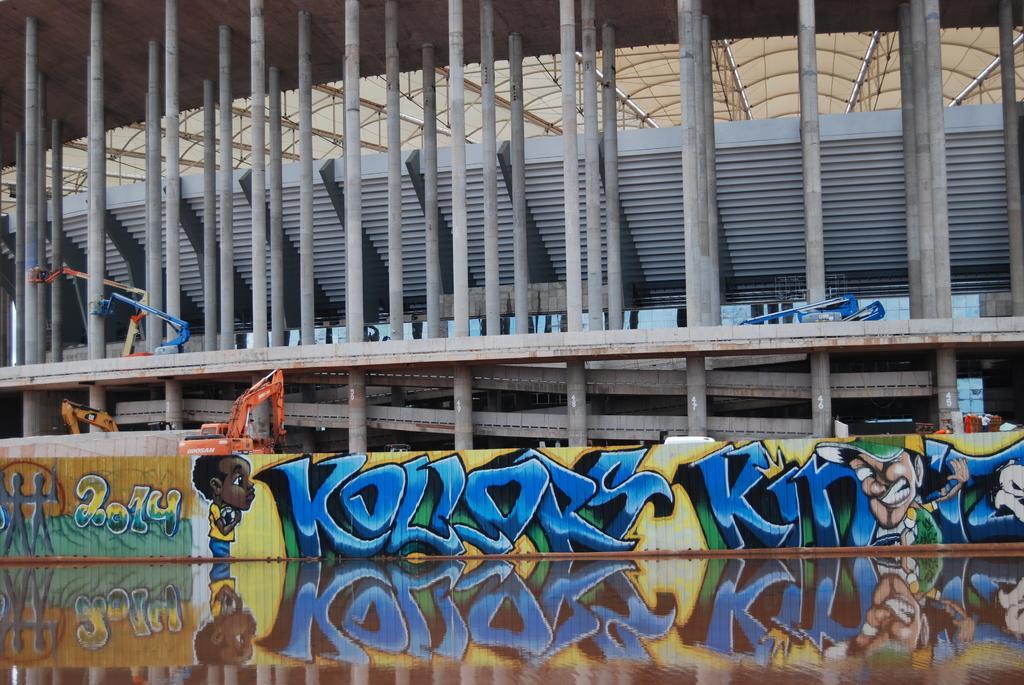Could you give a brief overview of what you see in this image? In the foreground of this image we can see the reflection of the painting of a person and the reflection of text and numbers. In the center we can see an object on which we can see the painting of persons and painting of text and numbers. In the background we can see the pillars, cranes, roof and some other objects. 